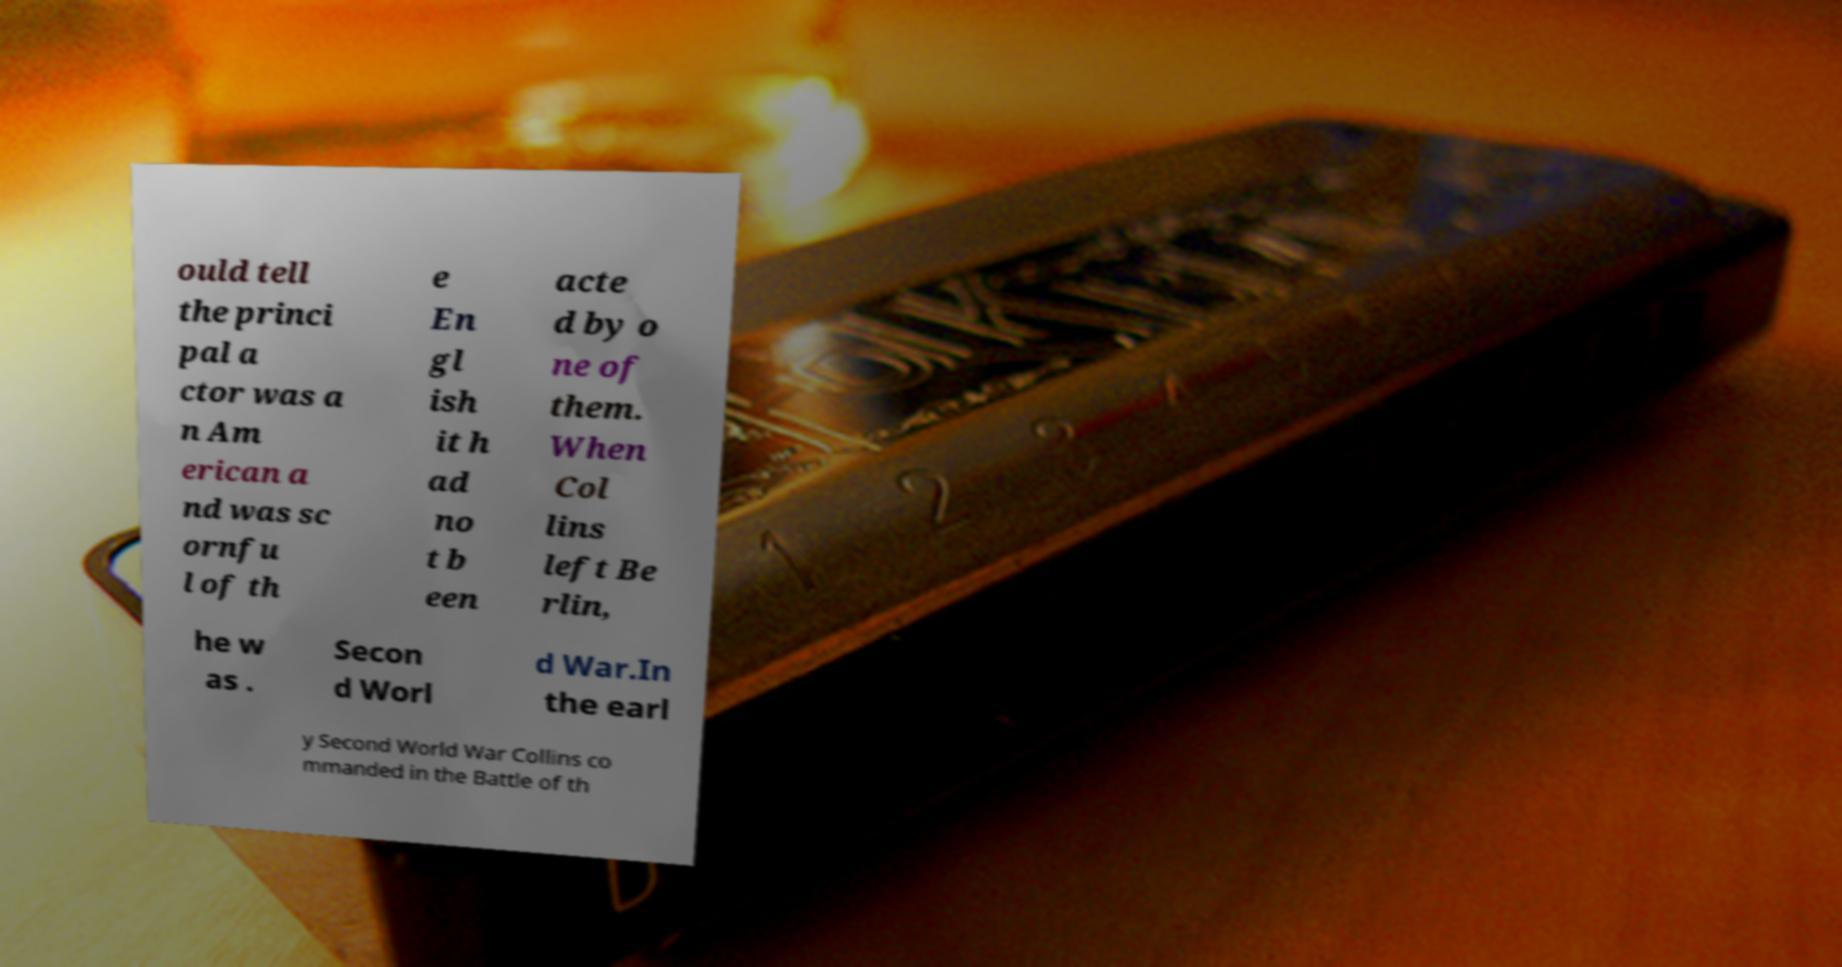Could you assist in decoding the text presented in this image and type it out clearly? ould tell the princi pal a ctor was a n Am erican a nd was sc ornfu l of th e En gl ish it h ad no t b een acte d by o ne of them. When Col lins left Be rlin, he w as . Secon d Worl d War.In the earl y Second World War Collins co mmanded in the Battle of th 